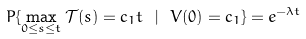<formula> <loc_0><loc_0><loc_500><loc_500>P \{ \max _ { 0 \leq s \leq t } \mathcal { T } ( s ) = c _ { 1 } t \ | \ V ( 0 ) = c _ { 1 } \} = e ^ { - \lambda t }</formula> 